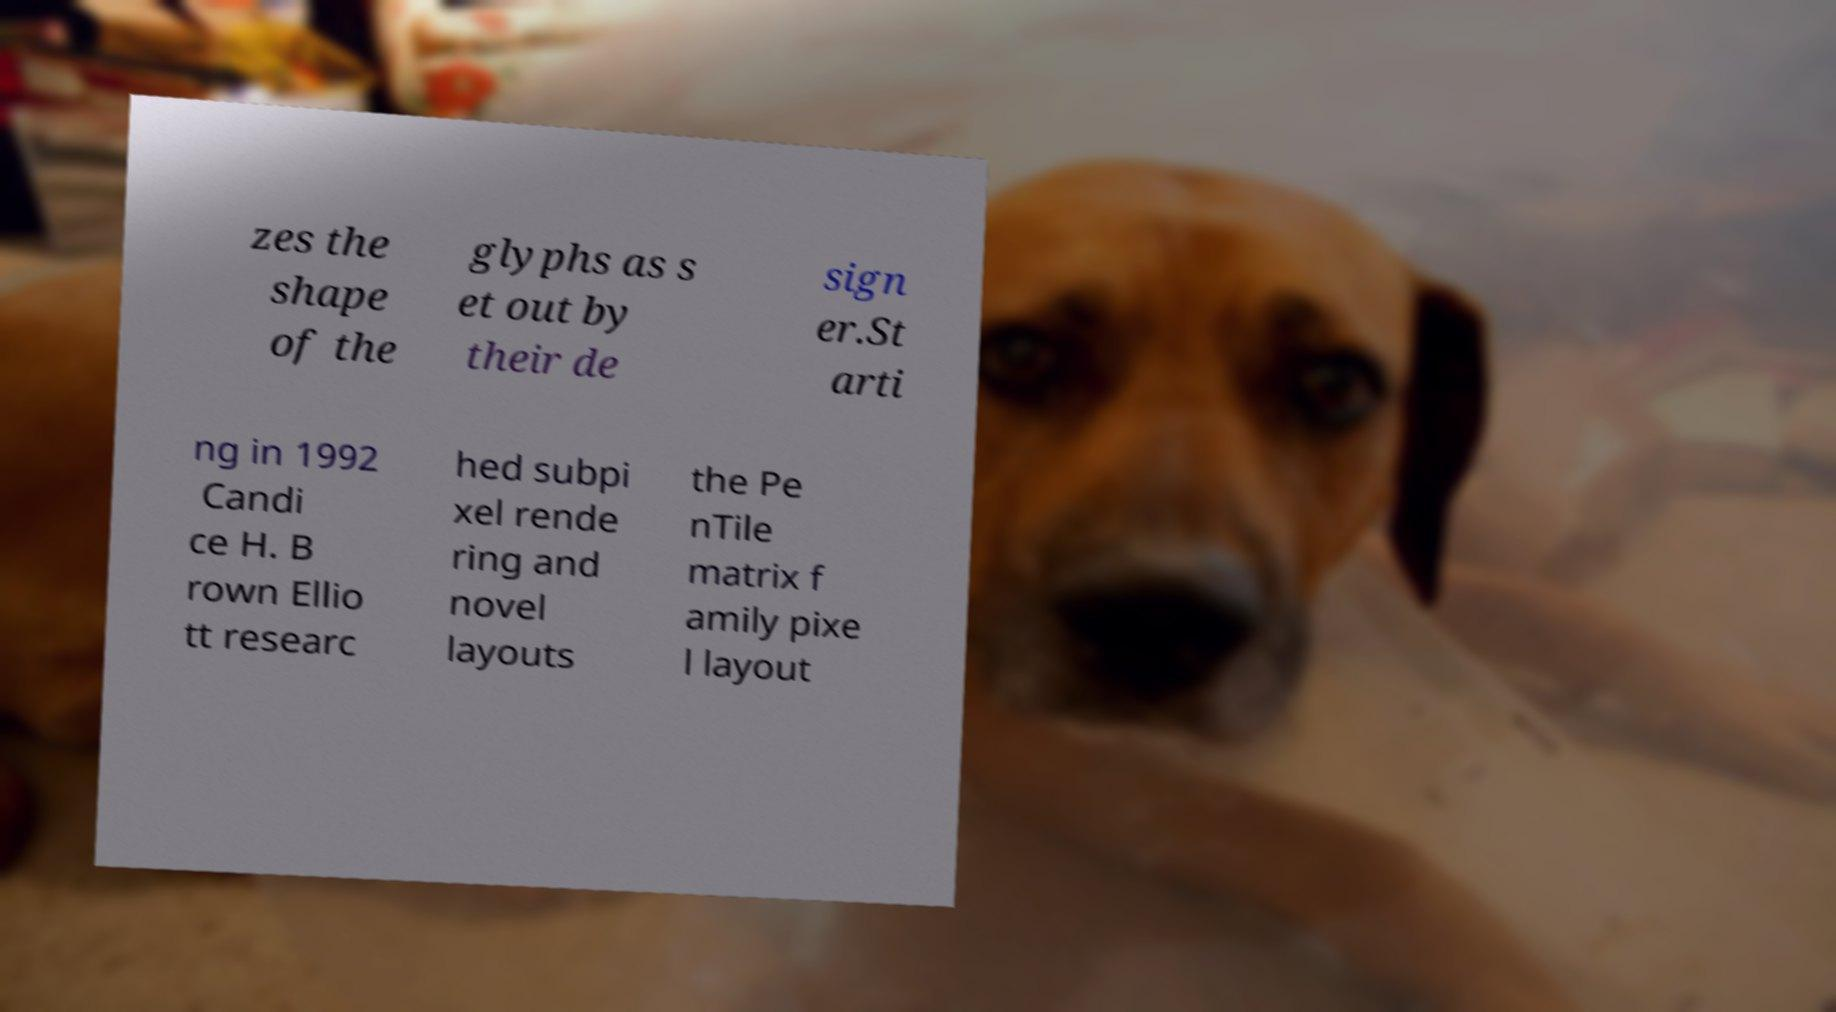Could you extract and type out the text from this image? zes the shape of the glyphs as s et out by their de sign er.St arti ng in 1992 Candi ce H. B rown Ellio tt researc hed subpi xel rende ring and novel layouts the Pe nTile matrix f amily pixe l layout 